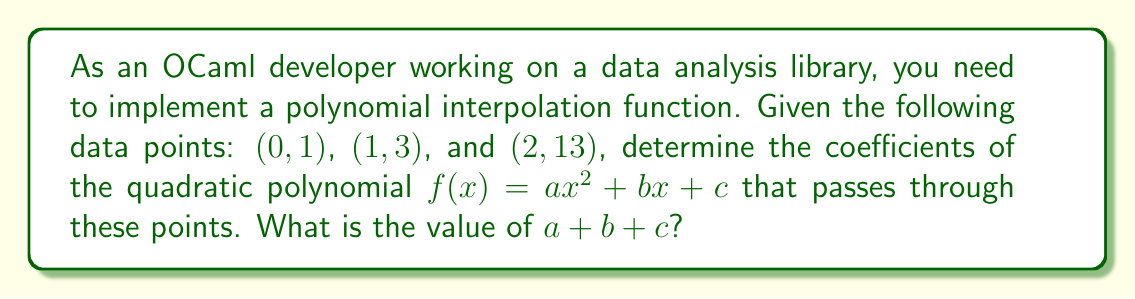What is the answer to this math problem? Let's approach this step-by-step:

1) We need to find $a$, $b$, and $c$ such that:
   $$f(0) = a(0)^2 + b(0) + c = 1$$
   $$f(1) = a(1)^2 + b(1) + c = 3$$
   $$f(2) = a(2)^2 + b(2) + c = 13$$

2) From the first equation:
   $$c = 1$$

3) Substituting this into the second equation:
   $$a + b + 1 = 3$$
   $$a + b = 2 \quad (1)$$

4) For the third equation:
   $$4a + 2b + 1 = 13$$
   $$4a + 2b = 12 \quad (2)$$

5) Multiply equation (1) by 2:
   $$2a + 2b = 4 \quad (3)$$

6) Subtract equation (3) from equation (2):
   $$2a = 8$$
   $$a = 4$$

7) Substitute this back into equation (1):
   $$4 + b = 2$$
   $$b = -2$$

8) We now have:
   $$a = 4$$
   $$b = -2$$
   $$c = 1$$

9) The sum $a + b + c$ is:
   $$4 + (-2) + 1 = 3$$
Answer: 3 